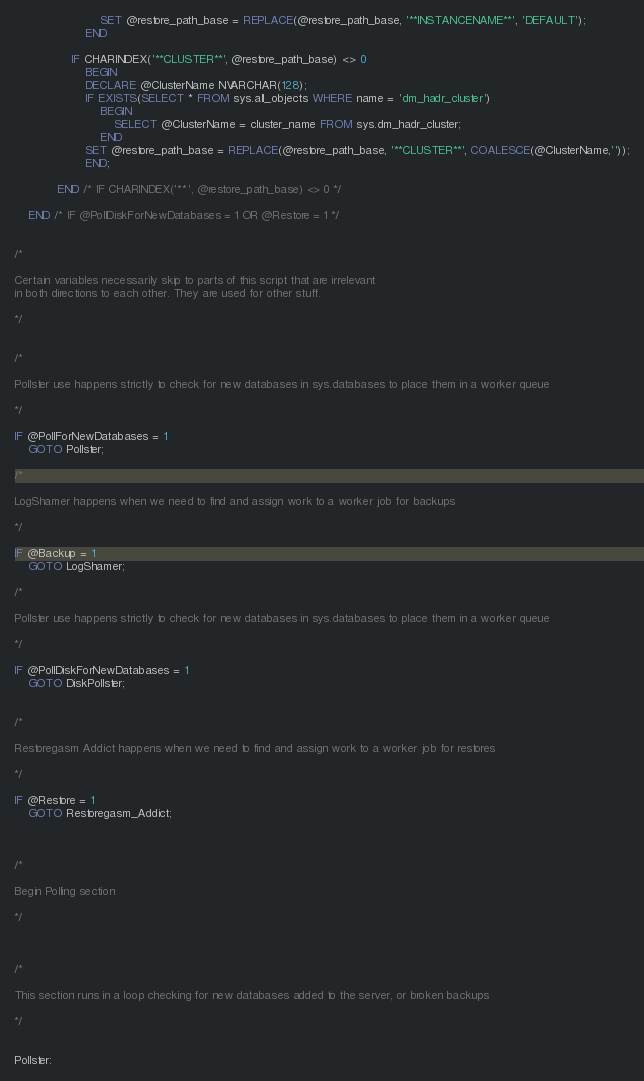<code> <loc_0><loc_0><loc_500><loc_500><_SQL_>                        SET @restore_path_base = REPLACE(@restore_path_base, '**INSTANCENAME**', 'DEFAULT');
                    END

                IF CHARINDEX('**CLUSTER**', @restore_path_base) <> 0
                    BEGIN
                    DECLARE @ClusterName NVARCHAR(128);
                    IF EXISTS(SELECT * FROM sys.all_objects WHERE name = 'dm_hadr_cluster')
                        BEGIN
                            SELECT @ClusterName = cluster_name FROM sys.dm_hadr_cluster;
                        END
                    SET @restore_path_base = REPLACE(@restore_path_base, '**CLUSTER**', COALESCE(@ClusterName,''));
                    END;

            END /* IF CHARINDEX('**', @restore_path_base) <> 0 */
                    
    END /* IF @PollDiskForNewDatabases = 1 OR @Restore = 1 */


/*

Certain variables necessarily skip to parts of this script that are irrelevant
in both directions to each other. They are used for other stuff.

*/


/*

Pollster use happens strictly to check for new databases in sys.databases to place them in a worker queue

*/

IF @PollForNewDatabases = 1
	GOTO Pollster;

/*

LogShamer happens when we need to find and assign work to a worker job for backups

*/

IF @Backup = 1
	GOTO LogShamer;

/*

Pollster use happens strictly to check for new databases in sys.databases to place them in a worker queue

*/

IF @PollDiskForNewDatabases = 1
	GOTO DiskPollster;


/*

Restoregasm Addict happens when we need to find and assign work to a worker job for restores

*/

IF @Restore = 1
	GOTO Restoregasm_Addict;



/*

Begin Polling section

*/



/*

This section runs in a loop checking for new databases added to the server, or broken backups

*/


Pollster:
</code> 